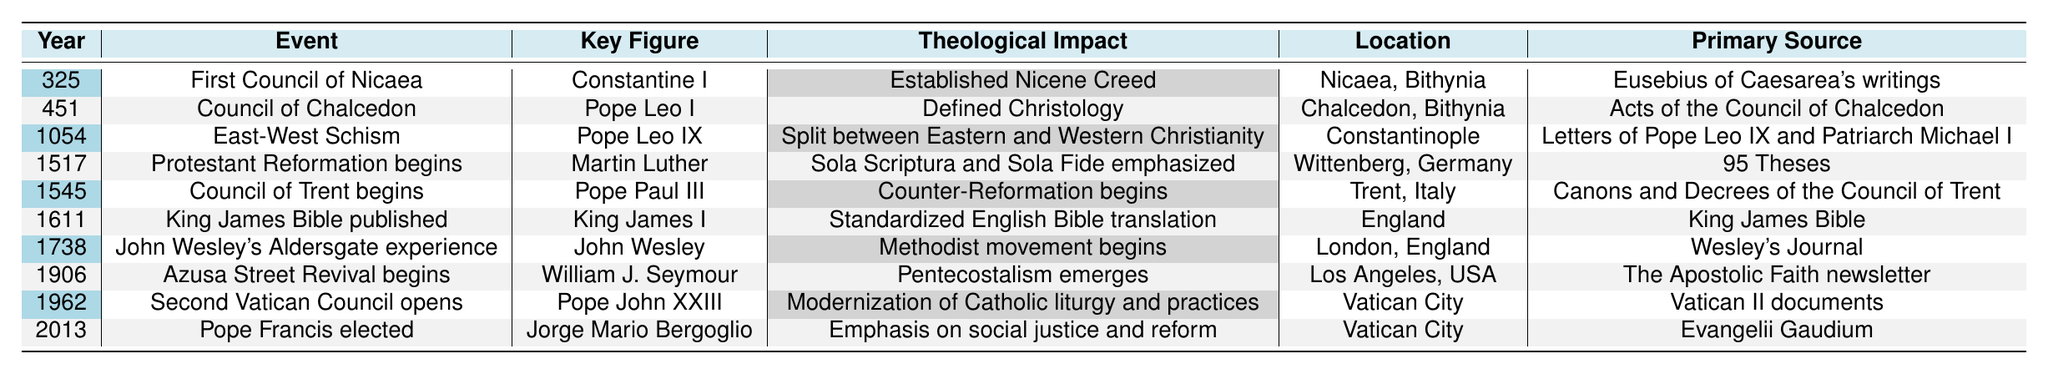What significant event occurred in 1054? According to the table, the event listed for 1054 is the East-West Schism.
Answer: East-West Schism Who was the key figure associated with the Protestant Reformation? The table indicates that Martin Luther was the key figure associated with the Protestant Reformation, which began in 1517.
Answer: Martin Luther Which event is linked to the publication of the King James Bible? The table states that the King James Bible was published in 1611, and it is related to King James I as the key figure.
Answer: King James Bible published What theological impact is associated with the Second Vatican Council? The table shows that the Second Vatican Council, which opened in 1962, modernized Catholic liturgy and practices.
Answer: Modernization of Catholic liturgy and practices How many events listed occurred before the 18th century? Looking at the years in the table, the events prior to the 18th century are in 325, 451, 1054, 1517, 1545, and 1611, totaling 6 events.
Answer: 6 Did the Azusa Street Revival begin before or after 1900? The table notes that the Azusa Street Revival began in 1906, which is after 1900.
Answer: After What is the primary source for the Council of Chalcedon? The table provides that the primary source for the Council of Chalcedon is the Acts of the Council of Chalcedon.
Answer: Acts of the Council of Chalcedon Which key figure is associated with the event that emphasized Sola Scriptura and Sola Fide? The event that emphasized Sola Scriptura and Sola Fide is the Protestant Reformation, and the associated key figure is Martin Luther.
Answer: Martin Luther Which two events took place in Vatican City? The table indicates the Second Vatican Council opened in 1962 and Pope Francis was elected in 2013, both occurring in Vatican City.
Answer: Second Vatican Council and Pope Francis elected Can you identify the event linked to the key figure John Wesley? The table shows that John Wesley's Aldersgate experience is the event linked to him.
Answer: John Wesley's Aldersgate experience What was the theological impact of the Council of Trent? The table states that the Council of Trent marked the beginning of the Counter-Reformation.
Answer: Counter-Reformation begins How many events involved Pope Leo as a key figure? The events involving Pope Leo as a key figure are the Council of Chalcedon in 451 and the East-West Schism in 1054, totaling 2 events.
Answer: 2 What was the common theme in the years 1545 and 1962 regarding church councils? In both years, 1545 for the Council of Trent and 1962 for the Second Vatican Council, they indicate significant councils held to address church practices and reforms.
Answer: Significant councils addressing church practices and reforms 